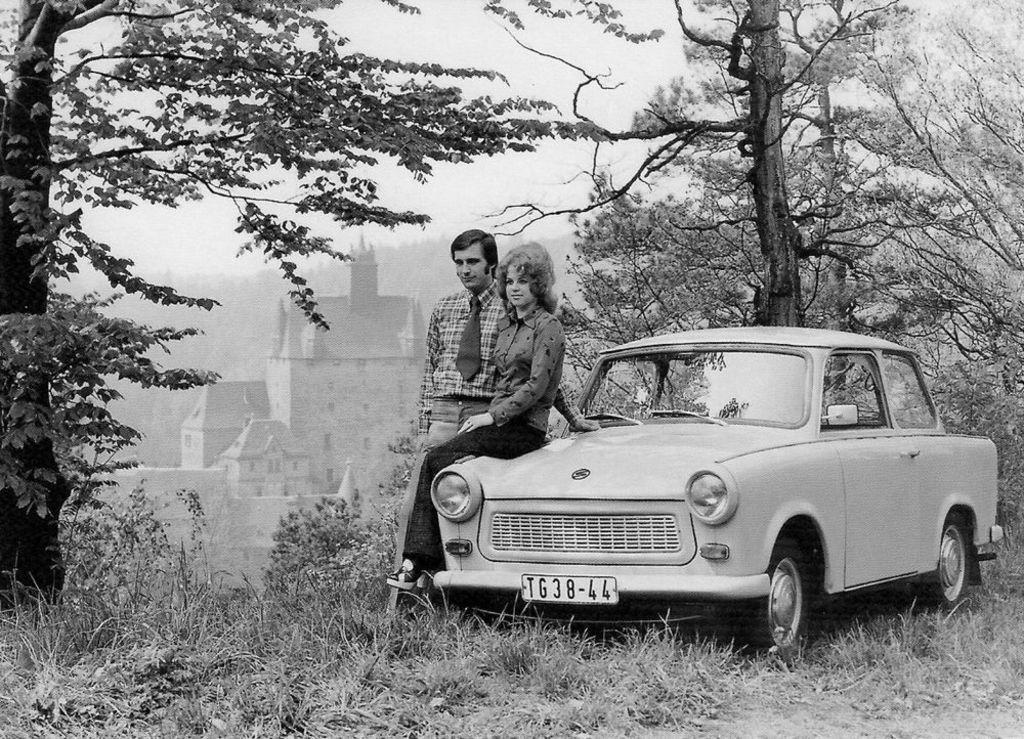Please provide a concise description of this image. This is a black and white image. In this image we can see there is a girl sitting on the car, beside her there is a person standing on the surface of the grass. On the right and left side of the image there are trees. In the background there is a building. 